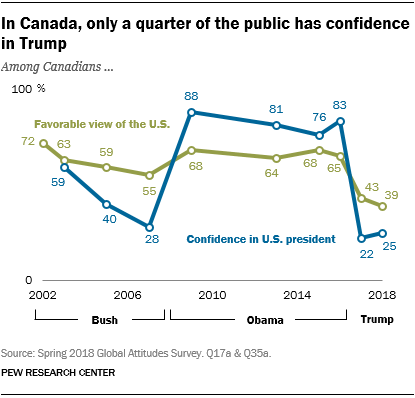Highlight a few significant elements in this photo. The highest value for the blue graph is approximately 0.88. The average of the highest and lowest values of the green bar is less than 80. 